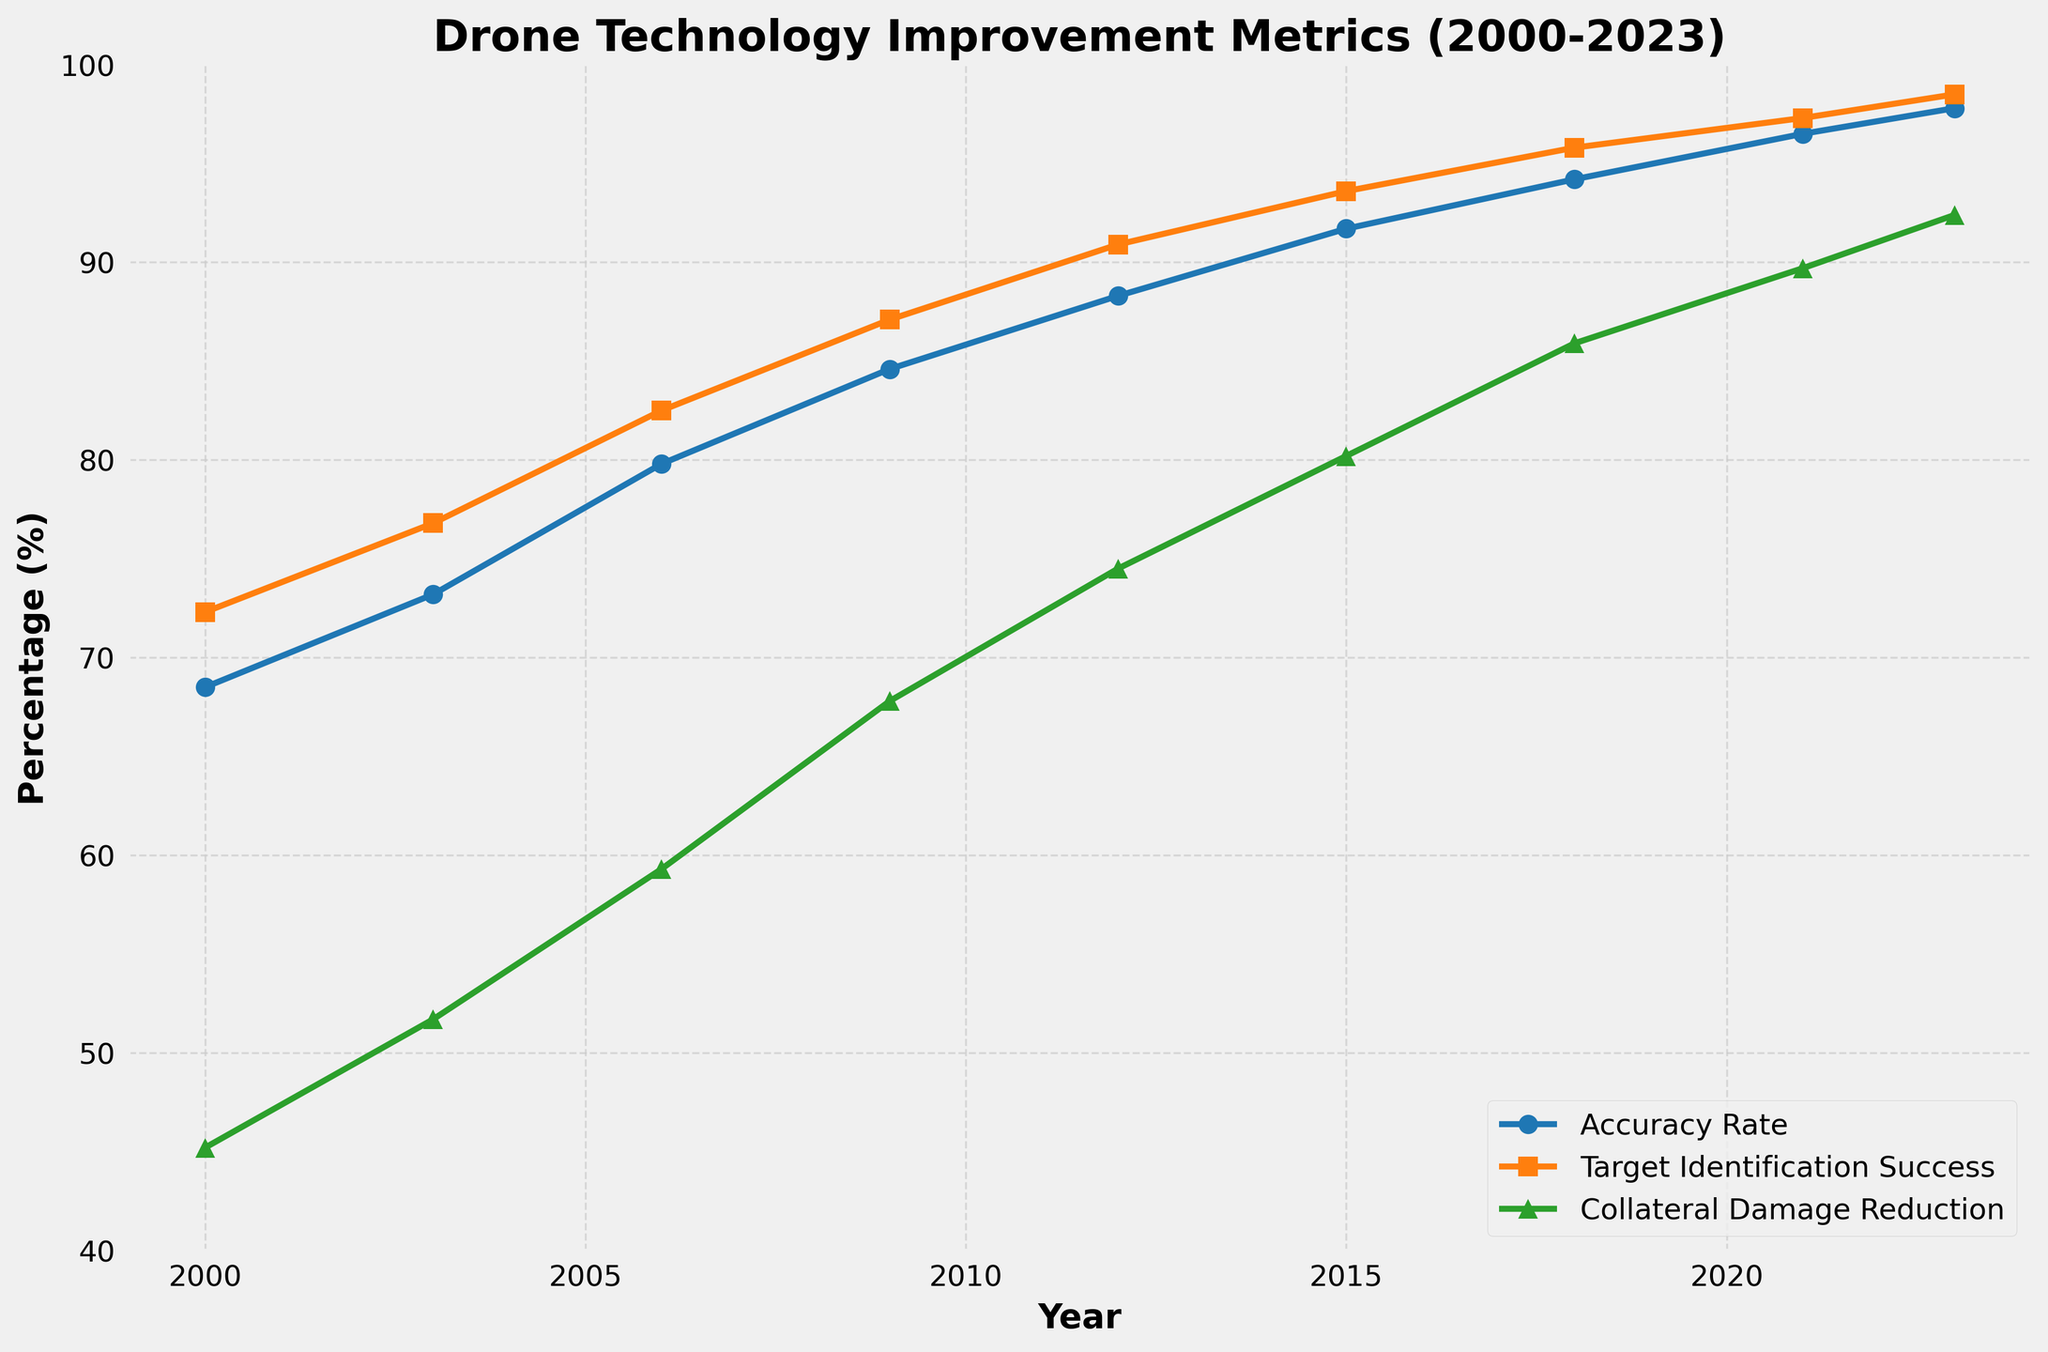What is the trend of the Accuracy Rate from 2000 to 2023? The Accuracy Rate increases over time from 68.5% in 2000 to 97.8% in 2023, showing a consistent improvement throughout the years.
Answer: It consistently increases Which metric showed the greatest improvement from 2000 to 2023? The Collateral Damage Reduction improved from 45.2% in 2000 to 92.4% in 2023, which is an improvement of 47.2 percentage points, the highest among the metrics.
Answer: Collateral Damage Reduction How does the Target Identification Success in 2015 compare to that in 2006? In 2006, the Target Identification Success is 82.5%, and in 2015 it is 93.6%. The improvement is 93.6% - 82.5% = 11.1 percentage points.
Answer: 11.1 percentage points higher In which year did the Accuracy Rate surpass 90%? The Accuracy Rate first surpassed 90% in the year 2015, reaching 91.7%.
Answer: 2015 What is the general trend observed for GPS Precision Meters from 2000 to 2023? The GPS Precision Meters decreases over time, which means an improvement in precision. It goes from 15 meters in 2000 to 0.3 meters in 2023.
Answer: It consistently decreases Compare the improvement in Accuracy Rate and Target Identification Success between 2000 and 2023. The Accuracy Rate improves from 68.5% to 97.8%, an increase of 29.3 percentage points. The Target Identification Success improves from 72.3% to 98.5%, an increase of 26.2 percentage points.
Answer: Accuracy Rate increased by 29.3, Target Identification Success by 26.2 By how much did the Collateral Damage Reduction increase from 2009 to 2023? The Collateral Damage Reduction in 2009 is 67.8% and in 2023 it is 92.4%. The increase is 92.4% - 67.8% = 24.6 percentage points.
Answer: 24.6 percentage points What year saw the largest single-year improvement in GPS Precision Meters, and what was the change? The largest single-year improvement in GPS Precision Meters occurred between 2009 and 2012 when precision improved from 5 meters to 3 meters, a 2-meter improvement.
Answer: Between 2009 and 2012, by 2 meters Which metric shows the least improvement over the years, and what might that indicate? The Target Identification Success shows the least improvement, increasing from 72.3% in 2000 to 98.5% in 2023, an increase of 26.2 percentage points. This might indicate that it was already relatively high and therefore had less room for improvement.
Answer: Target Identification Success What is the difference in Accuracy Rate between 2012 and 2023? The Accuracy Rate in 2012 is 88.3%, and in 2023 it is 97.8%, so the difference is 97.8% - 88.3% = 9.5 percentage points.
Answer: 9.5 percentage points 